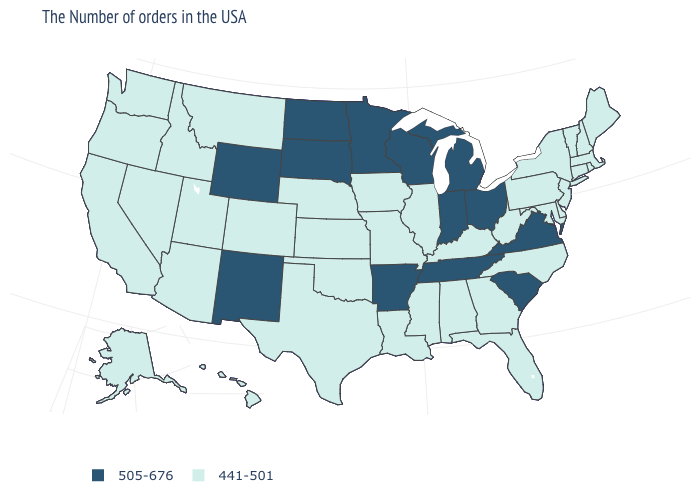Name the states that have a value in the range 505-676?
Concise answer only. Virginia, South Carolina, Ohio, Michigan, Indiana, Tennessee, Wisconsin, Arkansas, Minnesota, South Dakota, North Dakota, Wyoming, New Mexico. Is the legend a continuous bar?
Short answer required. No. Does Missouri have the same value as Hawaii?
Be succinct. Yes. Is the legend a continuous bar?
Quick response, please. No. Name the states that have a value in the range 441-501?
Write a very short answer. Maine, Massachusetts, Rhode Island, New Hampshire, Vermont, Connecticut, New York, New Jersey, Delaware, Maryland, Pennsylvania, North Carolina, West Virginia, Florida, Georgia, Kentucky, Alabama, Illinois, Mississippi, Louisiana, Missouri, Iowa, Kansas, Nebraska, Oklahoma, Texas, Colorado, Utah, Montana, Arizona, Idaho, Nevada, California, Washington, Oregon, Alaska, Hawaii. Does Nevada have a higher value than South Carolina?
Answer briefly. No. Does Vermont have the same value as Michigan?
Concise answer only. No. How many symbols are there in the legend?
Concise answer only. 2. Name the states that have a value in the range 441-501?
Give a very brief answer. Maine, Massachusetts, Rhode Island, New Hampshire, Vermont, Connecticut, New York, New Jersey, Delaware, Maryland, Pennsylvania, North Carolina, West Virginia, Florida, Georgia, Kentucky, Alabama, Illinois, Mississippi, Louisiana, Missouri, Iowa, Kansas, Nebraska, Oklahoma, Texas, Colorado, Utah, Montana, Arizona, Idaho, Nevada, California, Washington, Oregon, Alaska, Hawaii. Name the states that have a value in the range 441-501?
Concise answer only. Maine, Massachusetts, Rhode Island, New Hampshire, Vermont, Connecticut, New York, New Jersey, Delaware, Maryland, Pennsylvania, North Carolina, West Virginia, Florida, Georgia, Kentucky, Alabama, Illinois, Mississippi, Louisiana, Missouri, Iowa, Kansas, Nebraska, Oklahoma, Texas, Colorado, Utah, Montana, Arizona, Idaho, Nevada, California, Washington, Oregon, Alaska, Hawaii. Which states have the highest value in the USA?
Answer briefly. Virginia, South Carolina, Ohio, Michigan, Indiana, Tennessee, Wisconsin, Arkansas, Minnesota, South Dakota, North Dakota, Wyoming, New Mexico. Does the first symbol in the legend represent the smallest category?
Write a very short answer. No. What is the highest value in the USA?
Concise answer only. 505-676. Does the map have missing data?
Answer briefly. No. 